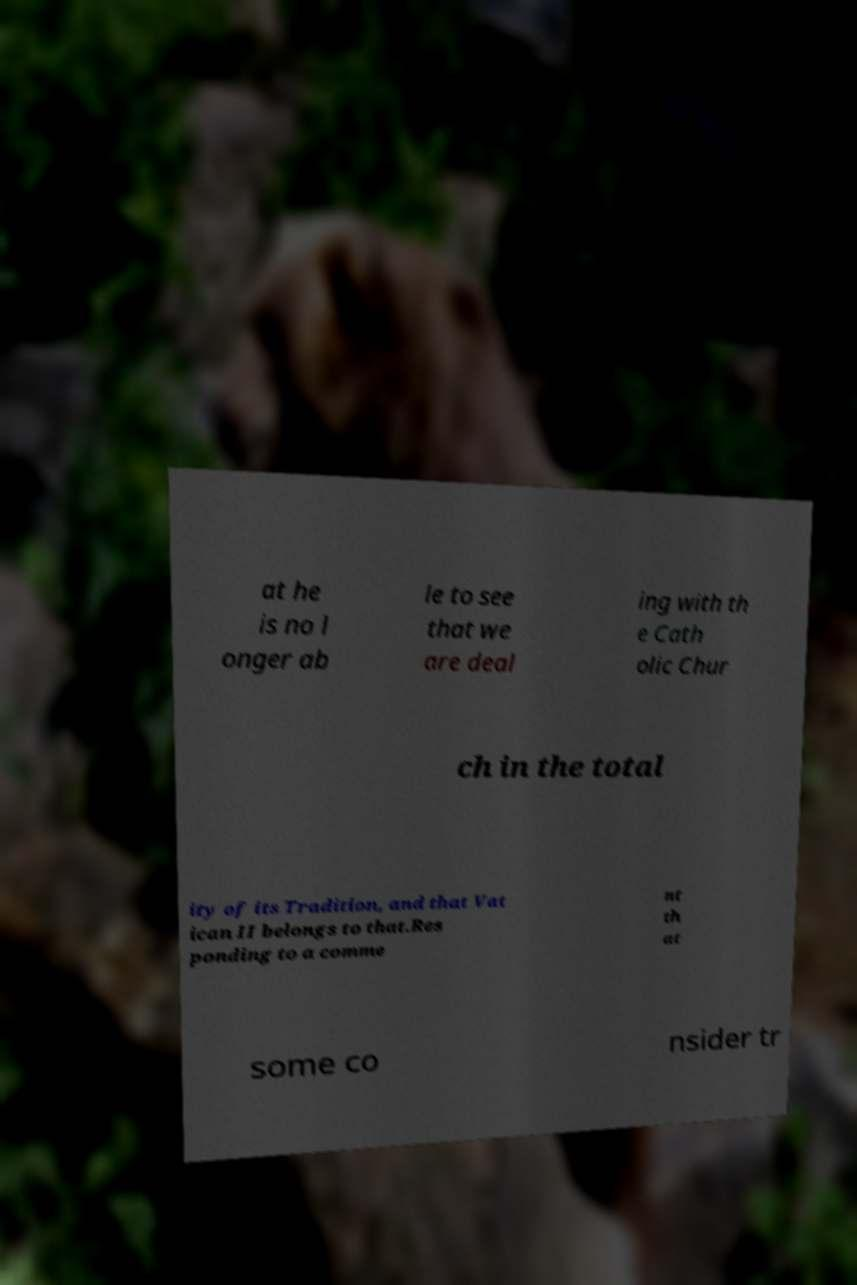Can you accurately transcribe the text from the provided image for me? at he is no l onger ab le to see that we are deal ing with th e Cath olic Chur ch in the total ity of its Tradition, and that Vat ican II belongs to that.Res ponding to a comme nt th at some co nsider tr 